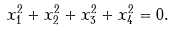Convert formula to latex. <formula><loc_0><loc_0><loc_500><loc_500>x _ { 1 } ^ { 2 } + x _ { 2 } ^ { 2 } + x _ { 3 } ^ { 2 } + x _ { 4 } ^ { 2 } = 0 .</formula> 